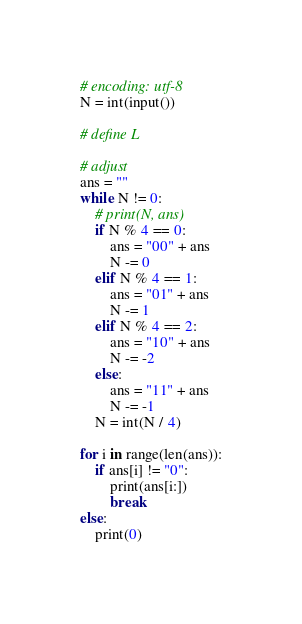Convert code to text. <code><loc_0><loc_0><loc_500><loc_500><_Python_># encoding: utf-8
N = int(input())

# define L

# adjust
ans = ""
while N != 0:
    # print(N, ans)
    if N % 4 == 0:
        ans = "00" + ans
        N -= 0
    elif N % 4 == 1:
        ans = "01" + ans
        N -= 1
    elif N % 4 == 2:
        ans = "10" + ans
        N -= -2
    else:
        ans = "11" + ans
        N -= -1
    N = int(N / 4)
    
for i in range(len(ans)):
    if ans[i] != "0":
        print(ans[i:])
        break
else:
    print(0)
</code> 